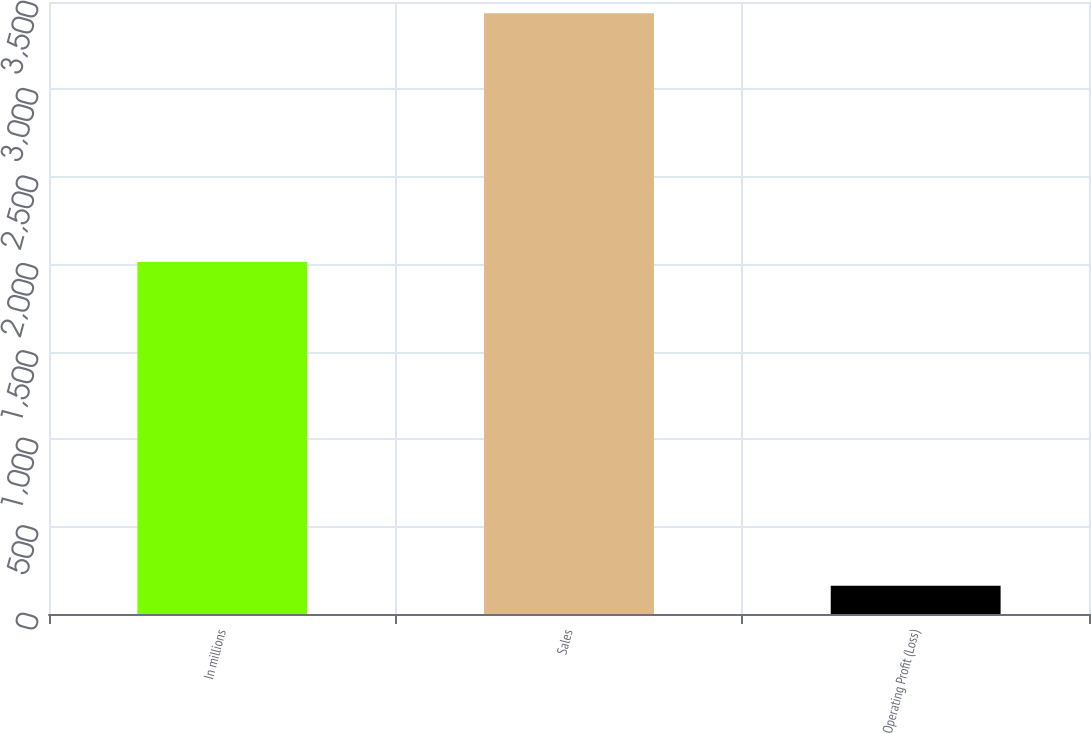Convert chart to OTSL. <chart><loc_0><loc_0><loc_500><loc_500><bar_chart><fcel>In millions<fcel>Sales<fcel>Operating Profit (Loss)<nl><fcel>2013<fcel>3435<fcel>161<nl></chart> 